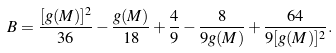Convert formula to latex. <formula><loc_0><loc_0><loc_500><loc_500>B = \frac { [ g ( M ) ] ^ { 2 } } { 3 6 } - \frac { g ( M ) } { 1 8 } + \frac { 4 } { 9 } - \frac { 8 } { 9 g ( M ) } + \frac { 6 4 } { 9 [ g ( M ) ] ^ { 2 } } .</formula> 